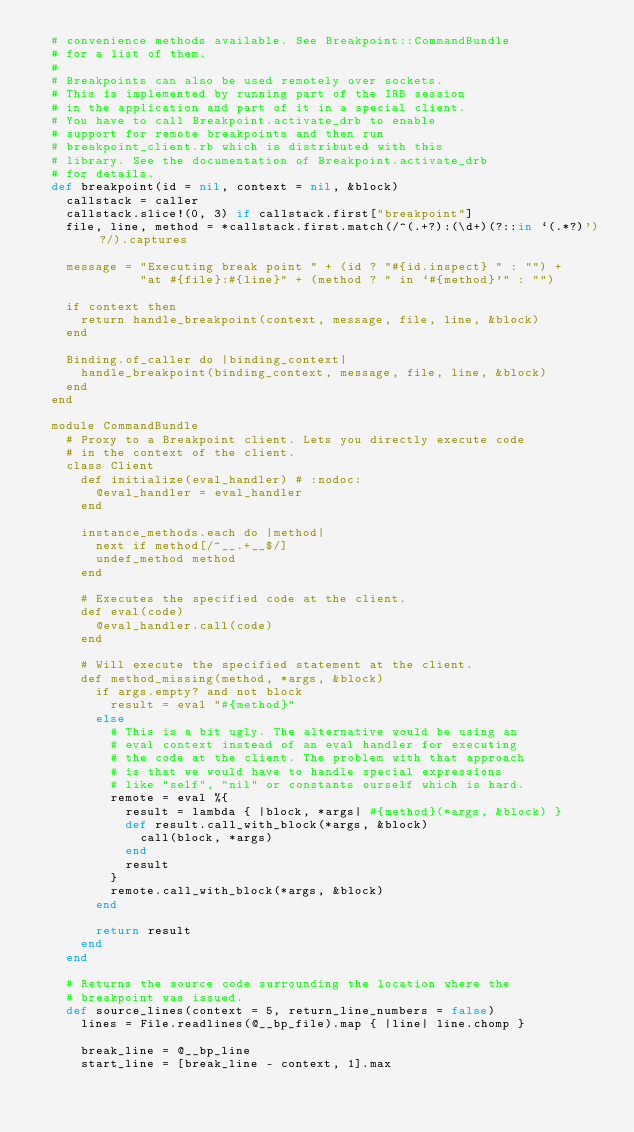<code> <loc_0><loc_0><loc_500><loc_500><_Ruby_>  # convenience methods available. See Breakpoint::CommandBundle
  # for a list of them.
  #
  # Breakpoints can also be used remotely over sockets.
  # This is implemented by running part of the IRB session
  # in the application and part of it in a special client.
  # You have to call Breakpoint.activate_drb to enable
  # support for remote breakpoints and then run
  # breakpoint_client.rb which is distributed with this
  # library. See the documentation of Breakpoint.activate_drb
  # for details.
  def breakpoint(id = nil, context = nil, &block)
    callstack = caller
    callstack.slice!(0, 3) if callstack.first["breakpoint"]
    file, line, method = *callstack.first.match(/^(.+?):(\d+)(?::in `(.*?)')?/).captures

    message = "Executing break point " + (id ? "#{id.inspect} " : "") +
              "at #{file}:#{line}" + (method ? " in `#{method}'" : "")

    if context then
      return handle_breakpoint(context, message, file, line, &block)
    end

    Binding.of_caller do |binding_context|
      handle_breakpoint(binding_context, message, file, line, &block)
    end
  end

  module CommandBundle
    # Proxy to a Breakpoint client. Lets you directly execute code
    # in the context of the client.
    class Client
      def initialize(eval_handler) # :nodoc:
        @eval_handler = eval_handler
      end

      instance_methods.each do |method|
        next if method[/^__.+__$/]
        undef_method method
      end

      # Executes the specified code at the client.
      def eval(code)
        @eval_handler.call(code)
      end

      # Will execute the specified statement at the client.
      def method_missing(method, *args, &block)
        if args.empty? and not block
          result = eval "#{method}"
        else
          # This is a bit ugly. The alternative would be using an
          # eval context instead of an eval handler for executing
          # the code at the client. The problem with that approach
          # is that we would have to handle special expressions
          # like "self", "nil" or constants ourself which is hard.
          remote = eval %{
            result = lambda { |block, *args| #{method}(*args, &block) }
            def result.call_with_block(*args, &block)
              call(block, *args)
            end
            result
          }
          remote.call_with_block(*args, &block)
        end

        return result
      end
    end

    # Returns the source code surrounding the location where the
    # breakpoint was issued.
    def source_lines(context = 5, return_line_numbers = false)
      lines = File.readlines(@__bp_file).map { |line| line.chomp }

      break_line = @__bp_line
      start_line = [break_line - context, 1].max</code> 